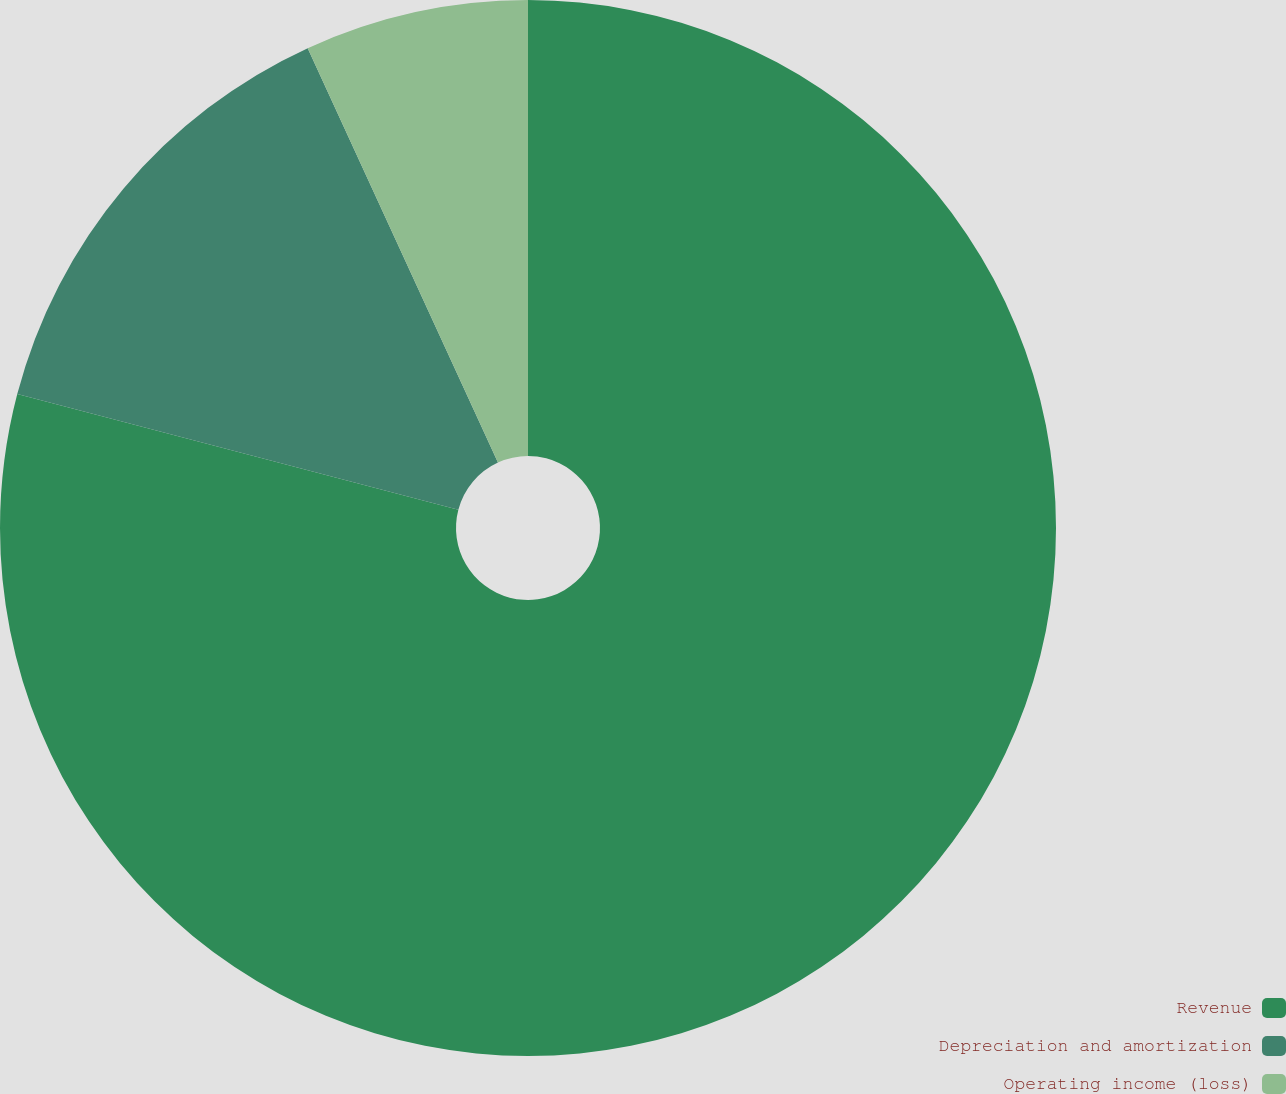Convert chart to OTSL. <chart><loc_0><loc_0><loc_500><loc_500><pie_chart><fcel>Revenue<fcel>Depreciation and amortization<fcel>Operating income (loss)<nl><fcel>79.08%<fcel>14.07%<fcel>6.85%<nl></chart> 